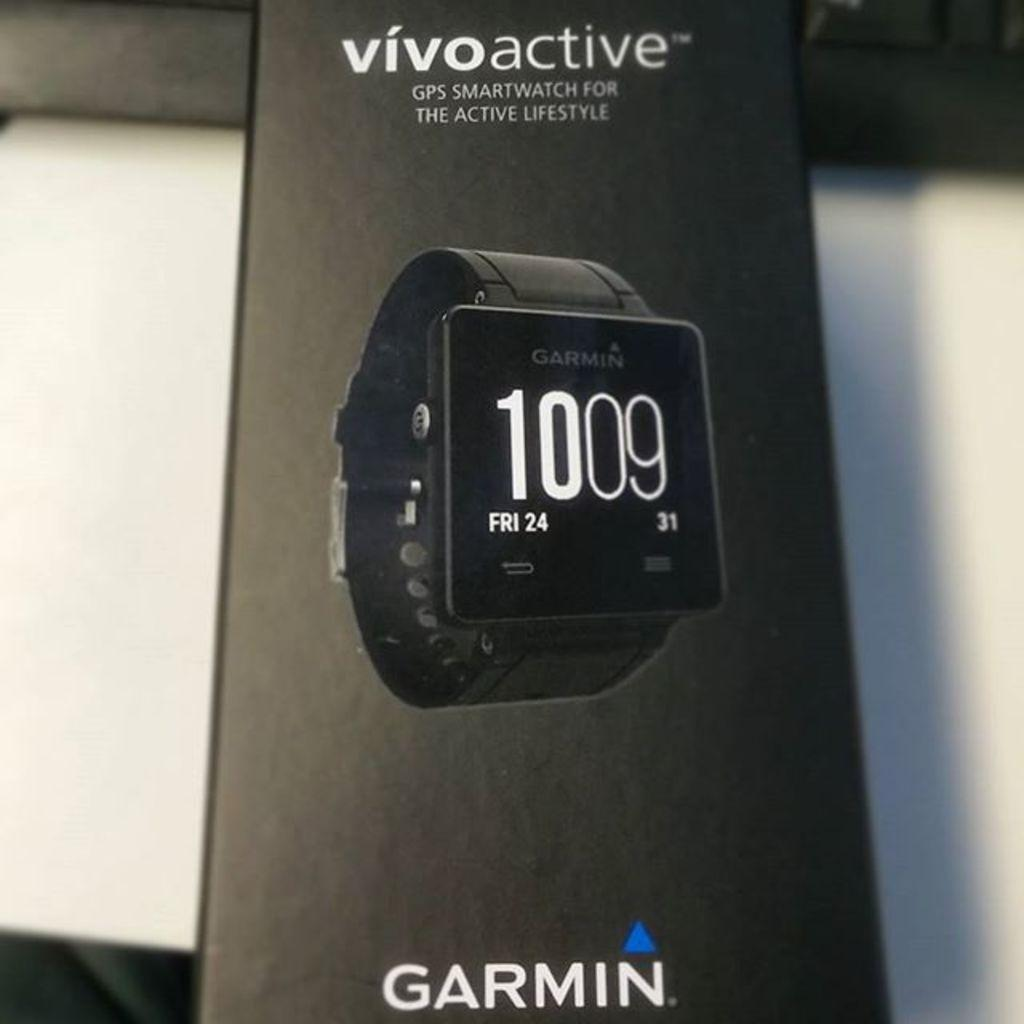<image>
Render a clear and concise summary of the photo. A Vivoactive watch reads 1009 on FRI 24. 